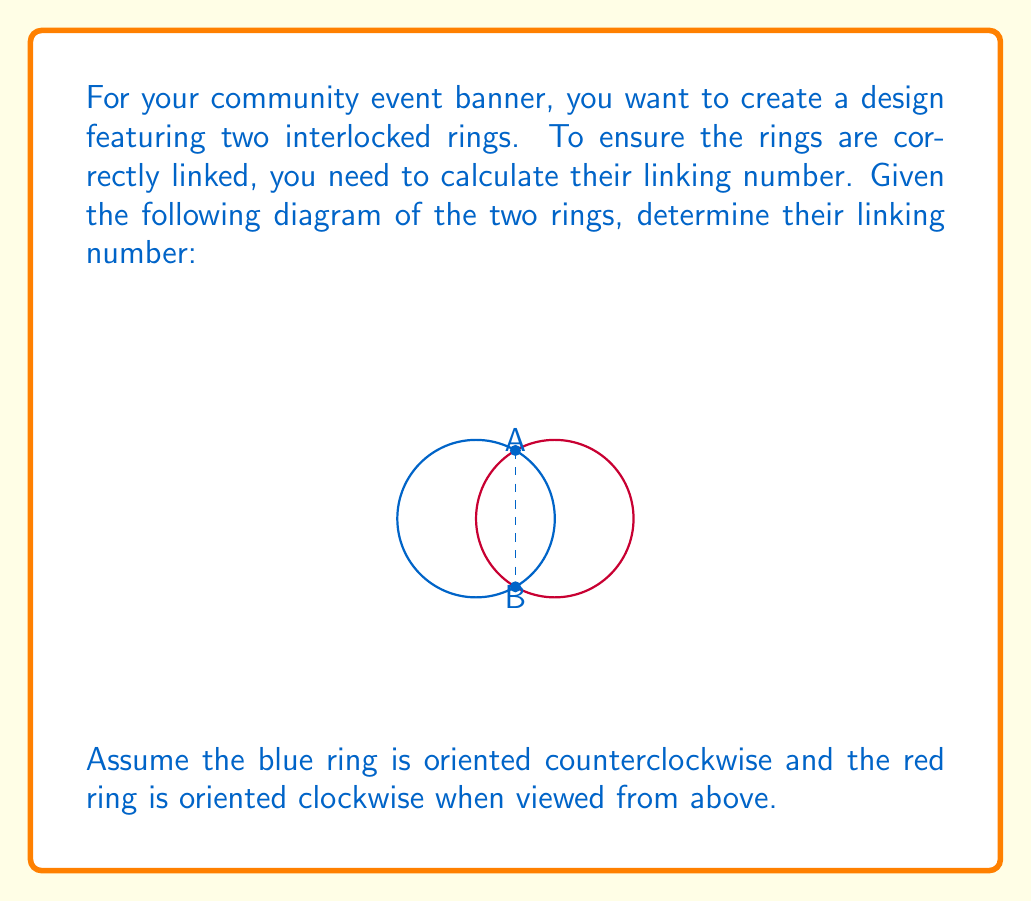What is the answer to this math problem? To calculate the linking number between two interlocked rings, we need to follow these steps:

1) Identify the crossing points: In this diagram, there are two crossing points, labeled A and B.

2) Determine the sign of each crossing:
   - At point A: The blue ring (going left to right) passes over the red ring (going right to left). This is a positive crossing (+1).
   - At point B: The blue ring (going right to left) passes under the red ring (going left to right). This is also a positive crossing (+1).

3) Calculate the linking number using the formula:

   $$ \text{Linking Number} = \frac{1}{2} \sum (\text{signs of crossings}) $$

4) Sum up the signs:
   $$(+1) + (+1) = +2$$

5) Apply the formula:
   $$ \text{Linking Number} = \frac{1}{2} (+2) = +1 $$

Therefore, the linking number between the two rings is +1.

This positive linking number indicates that the rings are indeed linked and cannot be separated without cutting one of them. The value of +1 is the simplest non-zero linking number, which is perfect for a clear and simple banner design.
Answer: $+1$ 